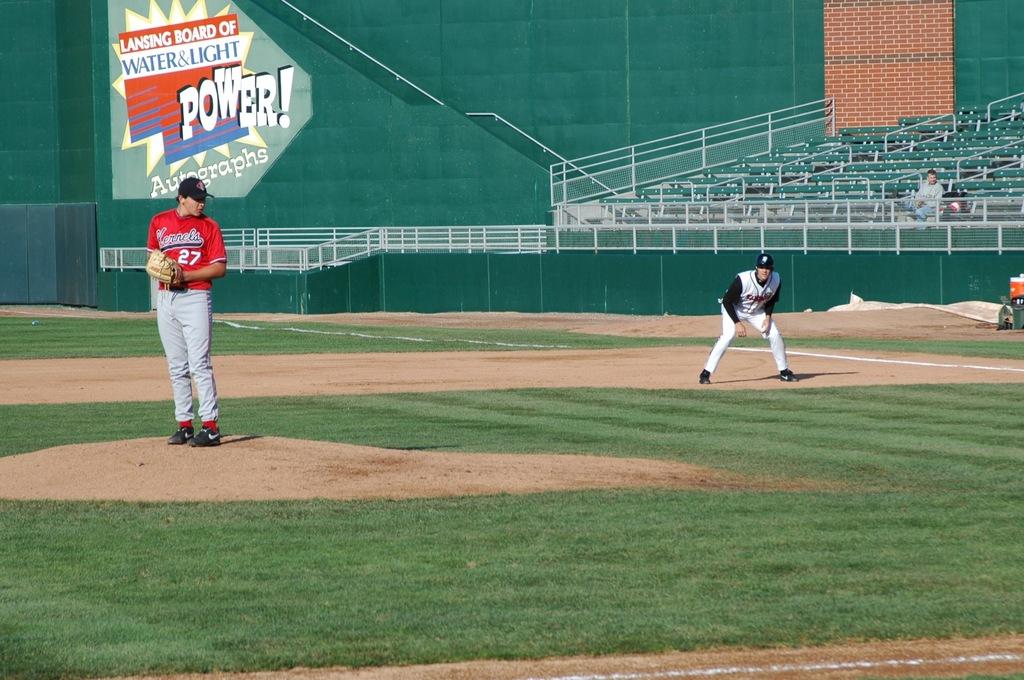What is the big word in the background?
Give a very brief answer. Power. What is written in bold on the sign behind the pitcher?
Your answer should be very brief. Power. 